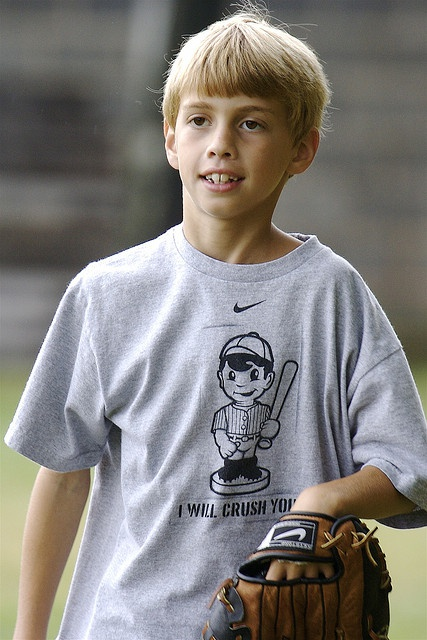Describe the objects in this image and their specific colors. I can see people in purple, darkgray, lavender, and gray tones and baseball glove in purple, black, maroon, darkgray, and gray tones in this image. 